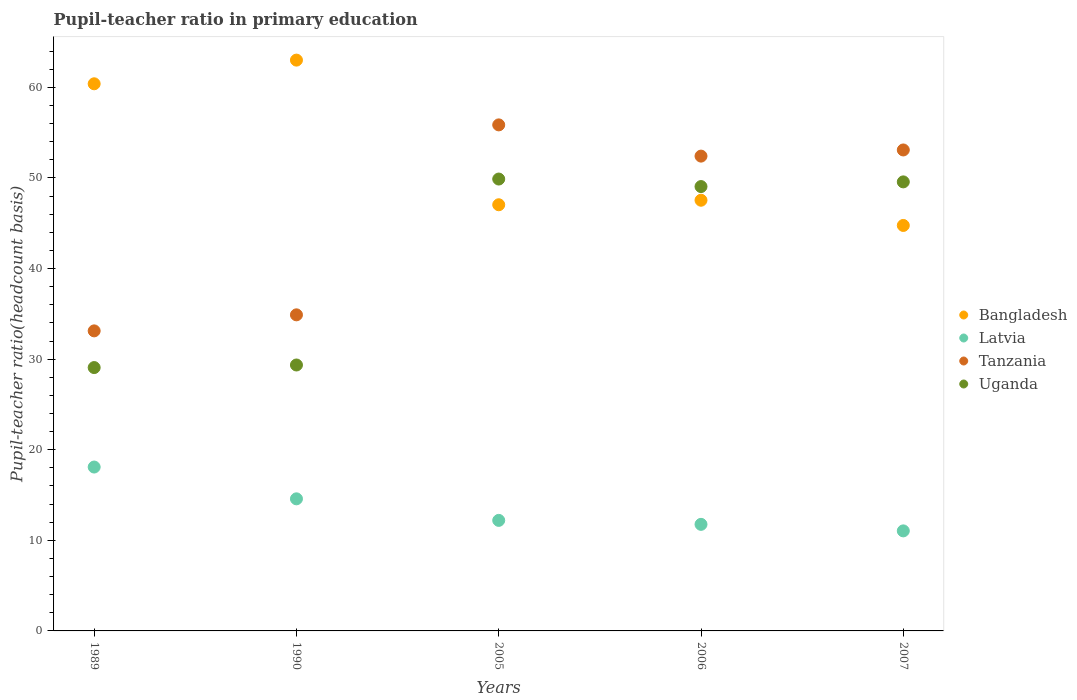How many different coloured dotlines are there?
Offer a very short reply. 4. Is the number of dotlines equal to the number of legend labels?
Give a very brief answer. Yes. What is the pupil-teacher ratio in primary education in Tanzania in 2006?
Keep it short and to the point. 52.41. Across all years, what is the maximum pupil-teacher ratio in primary education in Latvia?
Keep it short and to the point. 18.09. Across all years, what is the minimum pupil-teacher ratio in primary education in Latvia?
Keep it short and to the point. 11.04. In which year was the pupil-teacher ratio in primary education in Uganda minimum?
Offer a very short reply. 1989. What is the total pupil-teacher ratio in primary education in Tanzania in the graph?
Your answer should be compact. 229.36. What is the difference between the pupil-teacher ratio in primary education in Uganda in 1990 and that in 2007?
Make the answer very short. -20.21. What is the difference between the pupil-teacher ratio in primary education in Bangladesh in 1989 and the pupil-teacher ratio in primary education in Uganda in 1990?
Offer a very short reply. 31.04. What is the average pupil-teacher ratio in primary education in Bangladesh per year?
Keep it short and to the point. 52.55. In the year 2005, what is the difference between the pupil-teacher ratio in primary education in Tanzania and pupil-teacher ratio in primary education in Latvia?
Give a very brief answer. 43.65. In how many years, is the pupil-teacher ratio in primary education in Latvia greater than 38?
Your answer should be very brief. 0. What is the ratio of the pupil-teacher ratio in primary education in Bangladesh in 2006 to that in 2007?
Provide a short and direct response. 1.06. What is the difference between the highest and the second highest pupil-teacher ratio in primary education in Bangladesh?
Provide a succinct answer. 2.61. What is the difference between the highest and the lowest pupil-teacher ratio in primary education in Uganda?
Your answer should be compact. 20.81. In how many years, is the pupil-teacher ratio in primary education in Latvia greater than the average pupil-teacher ratio in primary education in Latvia taken over all years?
Your answer should be compact. 2. Is it the case that in every year, the sum of the pupil-teacher ratio in primary education in Tanzania and pupil-teacher ratio in primary education in Latvia  is greater than the sum of pupil-teacher ratio in primary education in Bangladesh and pupil-teacher ratio in primary education in Uganda?
Provide a short and direct response. Yes. Is the pupil-teacher ratio in primary education in Bangladesh strictly greater than the pupil-teacher ratio in primary education in Tanzania over the years?
Your response must be concise. No. How many years are there in the graph?
Offer a terse response. 5. Are the values on the major ticks of Y-axis written in scientific E-notation?
Offer a terse response. No. Does the graph contain any zero values?
Your answer should be very brief. No. Does the graph contain grids?
Provide a succinct answer. No. Where does the legend appear in the graph?
Offer a terse response. Center right. What is the title of the graph?
Your answer should be compact. Pupil-teacher ratio in primary education. Does "Cyprus" appear as one of the legend labels in the graph?
Keep it short and to the point. No. What is the label or title of the Y-axis?
Offer a very short reply. Pupil-teacher ratio(headcount basis). What is the Pupil-teacher ratio(headcount basis) of Bangladesh in 1989?
Your answer should be very brief. 60.39. What is the Pupil-teacher ratio(headcount basis) in Latvia in 1989?
Provide a succinct answer. 18.09. What is the Pupil-teacher ratio(headcount basis) in Tanzania in 1989?
Your answer should be very brief. 33.12. What is the Pupil-teacher ratio(headcount basis) in Uganda in 1989?
Make the answer very short. 29.07. What is the Pupil-teacher ratio(headcount basis) in Bangladesh in 1990?
Ensure brevity in your answer.  63. What is the Pupil-teacher ratio(headcount basis) of Latvia in 1990?
Provide a short and direct response. 14.58. What is the Pupil-teacher ratio(headcount basis) of Tanzania in 1990?
Your answer should be very brief. 34.89. What is the Pupil-teacher ratio(headcount basis) of Uganda in 1990?
Ensure brevity in your answer.  29.35. What is the Pupil-teacher ratio(headcount basis) of Bangladesh in 2005?
Make the answer very short. 47.04. What is the Pupil-teacher ratio(headcount basis) of Latvia in 2005?
Your response must be concise. 12.2. What is the Pupil-teacher ratio(headcount basis) in Tanzania in 2005?
Give a very brief answer. 55.86. What is the Pupil-teacher ratio(headcount basis) of Uganda in 2005?
Keep it short and to the point. 49.88. What is the Pupil-teacher ratio(headcount basis) in Bangladesh in 2006?
Give a very brief answer. 47.54. What is the Pupil-teacher ratio(headcount basis) in Latvia in 2006?
Your answer should be very brief. 11.76. What is the Pupil-teacher ratio(headcount basis) of Tanzania in 2006?
Your response must be concise. 52.41. What is the Pupil-teacher ratio(headcount basis) in Uganda in 2006?
Your response must be concise. 49.05. What is the Pupil-teacher ratio(headcount basis) in Bangladesh in 2007?
Offer a terse response. 44.75. What is the Pupil-teacher ratio(headcount basis) in Latvia in 2007?
Offer a terse response. 11.04. What is the Pupil-teacher ratio(headcount basis) in Tanzania in 2007?
Provide a succinct answer. 53.09. What is the Pupil-teacher ratio(headcount basis) of Uganda in 2007?
Make the answer very short. 49.56. Across all years, what is the maximum Pupil-teacher ratio(headcount basis) of Bangladesh?
Ensure brevity in your answer.  63. Across all years, what is the maximum Pupil-teacher ratio(headcount basis) of Latvia?
Make the answer very short. 18.09. Across all years, what is the maximum Pupil-teacher ratio(headcount basis) of Tanzania?
Give a very brief answer. 55.86. Across all years, what is the maximum Pupil-teacher ratio(headcount basis) in Uganda?
Offer a very short reply. 49.88. Across all years, what is the minimum Pupil-teacher ratio(headcount basis) in Bangladesh?
Offer a very short reply. 44.75. Across all years, what is the minimum Pupil-teacher ratio(headcount basis) of Latvia?
Provide a short and direct response. 11.04. Across all years, what is the minimum Pupil-teacher ratio(headcount basis) in Tanzania?
Keep it short and to the point. 33.12. Across all years, what is the minimum Pupil-teacher ratio(headcount basis) in Uganda?
Provide a succinct answer. 29.07. What is the total Pupil-teacher ratio(headcount basis) in Bangladesh in the graph?
Make the answer very short. 262.73. What is the total Pupil-teacher ratio(headcount basis) in Latvia in the graph?
Keep it short and to the point. 67.67. What is the total Pupil-teacher ratio(headcount basis) in Tanzania in the graph?
Provide a short and direct response. 229.36. What is the total Pupil-teacher ratio(headcount basis) of Uganda in the graph?
Your answer should be compact. 206.91. What is the difference between the Pupil-teacher ratio(headcount basis) of Bangladesh in 1989 and that in 1990?
Your answer should be very brief. -2.61. What is the difference between the Pupil-teacher ratio(headcount basis) in Latvia in 1989 and that in 1990?
Provide a short and direct response. 3.51. What is the difference between the Pupil-teacher ratio(headcount basis) in Tanzania in 1989 and that in 1990?
Your response must be concise. -1.77. What is the difference between the Pupil-teacher ratio(headcount basis) of Uganda in 1989 and that in 1990?
Your answer should be compact. -0.28. What is the difference between the Pupil-teacher ratio(headcount basis) of Bangladesh in 1989 and that in 2005?
Give a very brief answer. 13.35. What is the difference between the Pupil-teacher ratio(headcount basis) of Latvia in 1989 and that in 2005?
Make the answer very short. 5.89. What is the difference between the Pupil-teacher ratio(headcount basis) of Tanzania in 1989 and that in 2005?
Provide a succinct answer. -22.74. What is the difference between the Pupil-teacher ratio(headcount basis) in Uganda in 1989 and that in 2005?
Provide a short and direct response. -20.81. What is the difference between the Pupil-teacher ratio(headcount basis) in Bangladesh in 1989 and that in 2006?
Ensure brevity in your answer.  12.85. What is the difference between the Pupil-teacher ratio(headcount basis) in Latvia in 1989 and that in 2006?
Ensure brevity in your answer.  6.33. What is the difference between the Pupil-teacher ratio(headcount basis) of Tanzania in 1989 and that in 2006?
Keep it short and to the point. -19.29. What is the difference between the Pupil-teacher ratio(headcount basis) in Uganda in 1989 and that in 2006?
Your answer should be very brief. -19.98. What is the difference between the Pupil-teacher ratio(headcount basis) in Bangladesh in 1989 and that in 2007?
Offer a very short reply. 15.64. What is the difference between the Pupil-teacher ratio(headcount basis) of Latvia in 1989 and that in 2007?
Give a very brief answer. 7.05. What is the difference between the Pupil-teacher ratio(headcount basis) in Tanzania in 1989 and that in 2007?
Provide a short and direct response. -19.97. What is the difference between the Pupil-teacher ratio(headcount basis) in Uganda in 1989 and that in 2007?
Ensure brevity in your answer.  -20.5. What is the difference between the Pupil-teacher ratio(headcount basis) of Bangladesh in 1990 and that in 2005?
Ensure brevity in your answer.  15.97. What is the difference between the Pupil-teacher ratio(headcount basis) of Latvia in 1990 and that in 2005?
Your answer should be compact. 2.38. What is the difference between the Pupil-teacher ratio(headcount basis) of Tanzania in 1990 and that in 2005?
Your response must be concise. -20.97. What is the difference between the Pupil-teacher ratio(headcount basis) of Uganda in 1990 and that in 2005?
Provide a short and direct response. -20.52. What is the difference between the Pupil-teacher ratio(headcount basis) of Bangladesh in 1990 and that in 2006?
Offer a terse response. 15.47. What is the difference between the Pupil-teacher ratio(headcount basis) of Latvia in 1990 and that in 2006?
Ensure brevity in your answer.  2.82. What is the difference between the Pupil-teacher ratio(headcount basis) in Tanzania in 1990 and that in 2006?
Make the answer very short. -17.52. What is the difference between the Pupil-teacher ratio(headcount basis) in Uganda in 1990 and that in 2006?
Offer a terse response. -19.69. What is the difference between the Pupil-teacher ratio(headcount basis) in Bangladesh in 1990 and that in 2007?
Your answer should be compact. 18.25. What is the difference between the Pupil-teacher ratio(headcount basis) of Latvia in 1990 and that in 2007?
Your answer should be very brief. 3.54. What is the difference between the Pupil-teacher ratio(headcount basis) of Tanzania in 1990 and that in 2007?
Offer a very short reply. -18.2. What is the difference between the Pupil-teacher ratio(headcount basis) in Uganda in 1990 and that in 2007?
Keep it short and to the point. -20.21. What is the difference between the Pupil-teacher ratio(headcount basis) of Bangladesh in 2005 and that in 2006?
Your answer should be compact. -0.5. What is the difference between the Pupil-teacher ratio(headcount basis) in Latvia in 2005 and that in 2006?
Your answer should be very brief. 0.44. What is the difference between the Pupil-teacher ratio(headcount basis) in Tanzania in 2005 and that in 2006?
Your response must be concise. 3.45. What is the difference between the Pupil-teacher ratio(headcount basis) in Uganda in 2005 and that in 2006?
Offer a very short reply. 0.83. What is the difference between the Pupil-teacher ratio(headcount basis) in Bangladesh in 2005 and that in 2007?
Your response must be concise. 2.28. What is the difference between the Pupil-teacher ratio(headcount basis) in Latvia in 2005 and that in 2007?
Offer a terse response. 1.16. What is the difference between the Pupil-teacher ratio(headcount basis) in Tanzania in 2005 and that in 2007?
Your response must be concise. 2.77. What is the difference between the Pupil-teacher ratio(headcount basis) in Uganda in 2005 and that in 2007?
Your answer should be compact. 0.31. What is the difference between the Pupil-teacher ratio(headcount basis) in Bangladesh in 2006 and that in 2007?
Your response must be concise. 2.78. What is the difference between the Pupil-teacher ratio(headcount basis) of Latvia in 2006 and that in 2007?
Provide a succinct answer. 0.72. What is the difference between the Pupil-teacher ratio(headcount basis) of Tanzania in 2006 and that in 2007?
Provide a succinct answer. -0.68. What is the difference between the Pupil-teacher ratio(headcount basis) in Uganda in 2006 and that in 2007?
Give a very brief answer. -0.52. What is the difference between the Pupil-teacher ratio(headcount basis) of Bangladesh in 1989 and the Pupil-teacher ratio(headcount basis) of Latvia in 1990?
Provide a succinct answer. 45.81. What is the difference between the Pupil-teacher ratio(headcount basis) in Bangladesh in 1989 and the Pupil-teacher ratio(headcount basis) in Tanzania in 1990?
Offer a very short reply. 25.5. What is the difference between the Pupil-teacher ratio(headcount basis) of Bangladesh in 1989 and the Pupil-teacher ratio(headcount basis) of Uganda in 1990?
Offer a very short reply. 31.04. What is the difference between the Pupil-teacher ratio(headcount basis) in Latvia in 1989 and the Pupil-teacher ratio(headcount basis) in Tanzania in 1990?
Your answer should be very brief. -16.8. What is the difference between the Pupil-teacher ratio(headcount basis) of Latvia in 1989 and the Pupil-teacher ratio(headcount basis) of Uganda in 1990?
Ensure brevity in your answer.  -11.26. What is the difference between the Pupil-teacher ratio(headcount basis) of Tanzania in 1989 and the Pupil-teacher ratio(headcount basis) of Uganda in 1990?
Keep it short and to the point. 3.77. What is the difference between the Pupil-teacher ratio(headcount basis) in Bangladesh in 1989 and the Pupil-teacher ratio(headcount basis) in Latvia in 2005?
Give a very brief answer. 48.19. What is the difference between the Pupil-teacher ratio(headcount basis) in Bangladesh in 1989 and the Pupil-teacher ratio(headcount basis) in Tanzania in 2005?
Provide a succinct answer. 4.54. What is the difference between the Pupil-teacher ratio(headcount basis) in Bangladesh in 1989 and the Pupil-teacher ratio(headcount basis) in Uganda in 2005?
Give a very brief answer. 10.51. What is the difference between the Pupil-teacher ratio(headcount basis) of Latvia in 1989 and the Pupil-teacher ratio(headcount basis) of Tanzania in 2005?
Keep it short and to the point. -37.77. What is the difference between the Pupil-teacher ratio(headcount basis) of Latvia in 1989 and the Pupil-teacher ratio(headcount basis) of Uganda in 2005?
Your answer should be very brief. -31.79. What is the difference between the Pupil-teacher ratio(headcount basis) of Tanzania in 1989 and the Pupil-teacher ratio(headcount basis) of Uganda in 2005?
Ensure brevity in your answer.  -16.76. What is the difference between the Pupil-teacher ratio(headcount basis) in Bangladesh in 1989 and the Pupil-teacher ratio(headcount basis) in Latvia in 2006?
Ensure brevity in your answer.  48.63. What is the difference between the Pupil-teacher ratio(headcount basis) of Bangladesh in 1989 and the Pupil-teacher ratio(headcount basis) of Tanzania in 2006?
Your answer should be very brief. 7.98. What is the difference between the Pupil-teacher ratio(headcount basis) of Bangladesh in 1989 and the Pupil-teacher ratio(headcount basis) of Uganda in 2006?
Your response must be concise. 11.34. What is the difference between the Pupil-teacher ratio(headcount basis) of Latvia in 1989 and the Pupil-teacher ratio(headcount basis) of Tanzania in 2006?
Give a very brief answer. -34.32. What is the difference between the Pupil-teacher ratio(headcount basis) of Latvia in 1989 and the Pupil-teacher ratio(headcount basis) of Uganda in 2006?
Offer a terse response. -30.96. What is the difference between the Pupil-teacher ratio(headcount basis) in Tanzania in 1989 and the Pupil-teacher ratio(headcount basis) in Uganda in 2006?
Make the answer very short. -15.93. What is the difference between the Pupil-teacher ratio(headcount basis) in Bangladesh in 1989 and the Pupil-teacher ratio(headcount basis) in Latvia in 2007?
Provide a succinct answer. 49.35. What is the difference between the Pupil-teacher ratio(headcount basis) of Bangladesh in 1989 and the Pupil-teacher ratio(headcount basis) of Tanzania in 2007?
Provide a succinct answer. 7.3. What is the difference between the Pupil-teacher ratio(headcount basis) of Bangladesh in 1989 and the Pupil-teacher ratio(headcount basis) of Uganda in 2007?
Offer a very short reply. 10.83. What is the difference between the Pupil-teacher ratio(headcount basis) of Latvia in 1989 and the Pupil-teacher ratio(headcount basis) of Tanzania in 2007?
Offer a terse response. -35. What is the difference between the Pupil-teacher ratio(headcount basis) of Latvia in 1989 and the Pupil-teacher ratio(headcount basis) of Uganda in 2007?
Your response must be concise. -31.48. What is the difference between the Pupil-teacher ratio(headcount basis) of Tanzania in 1989 and the Pupil-teacher ratio(headcount basis) of Uganda in 2007?
Your answer should be compact. -16.45. What is the difference between the Pupil-teacher ratio(headcount basis) in Bangladesh in 1990 and the Pupil-teacher ratio(headcount basis) in Latvia in 2005?
Provide a succinct answer. 50.8. What is the difference between the Pupil-teacher ratio(headcount basis) of Bangladesh in 1990 and the Pupil-teacher ratio(headcount basis) of Tanzania in 2005?
Ensure brevity in your answer.  7.15. What is the difference between the Pupil-teacher ratio(headcount basis) of Bangladesh in 1990 and the Pupil-teacher ratio(headcount basis) of Uganda in 2005?
Offer a very short reply. 13.13. What is the difference between the Pupil-teacher ratio(headcount basis) in Latvia in 1990 and the Pupil-teacher ratio(headcount basis) in Tanzania in 2005?
Provide a short and direct response. -41.28. What is the difference between the Pupil-teacher ratio(headcount basis) of Latvia in 1990 and the Pupil-teacher ratio(headcount basis) of Uganda in 2005?
Make the answer very short. -35.3. What is the difference between the Pupil-teacher ratio(headcount basis) of Tanzania in 1990 and the Pupil-teacher ratio(headcount basis) of Uganda in 2005?
Offer a very short reply. -14.99. What is the difference between the Pupil-teacher ratio(headcount basis) in Bangladesh in 1990 and the Pupil-teacher ratio(headcount basis) in Latvia in 2006?
Your answer should be compact. 51.24. What is the difference between the Pupil-teacher ratio(headcount basis) of Bangladesh in 1990 and the Pupil-teacher ratio(headcount basis) of Tanzania in 2006?
Offer a terse response. 10.6. What is the difference between the Pupil-teacher ratio(headcount basis) in Bangladesh in 1990 and the Pupil-teacher ratio(headcount basis) in Uganda in 2006?
Your response must be concise. 13.96. What is the difference between the Pupil-teacher ratio(headcount basis) of Latvia in 1990 and the Pupil-teacher ratio(headcount basis) of Tanzania in 2006?
Give a very brief answer. -37.83. What is the difference between the Pupil-teacher ratio(headcount basis) in Latvia in 1990 and the Pupil-teacher ratio(headcount basis) in Uganda in 2006?
Give a very brief answer. -34.47. What is the difference between the Pupil-teacher ratio(headcount basis) of Tanzania in 1990 and the Pupil-teacher ratio(headcount basis) of Uganda in 2006?
Offer a very short reply. -14.16. What is the difference between the Pupil-teacher ratio(headcount basis) in Bangladesh in 1990 and the Pupil-teacher ratio(headcount basis) in Latvia in 2007?
Your response must be concise. 51.96. What is the difference between the Pupil-teacher ratio(headcount basis) of Bangladesh in 1990 and the Pupil-teacher ratio(headcount basis) of Tanzania in 2007?
Offer a terse response. 9.92. What is the difference between the Pupil-teacher ratio(headcount basis) in Bangladesh in 1990 and the Pupil-teacher ratio(headcount basis) in Uganda in 2007?
Offer a very short reply. 13.44. What is the difference between the Pupil-teacher ratio(headcount basis) of Latvia in 1990 and the Pupil-teacher ratio(headcount basis) of Tanzania in 2007?
Make the answer very short. -38.51. What is the difference between the Pupil-teacher ratio(headcount basis) in Latvia in 1990 and the Pupil-teacher ratio(headcount basis) in Uganda in 2007?
Make the answer very short. -34.98. What is the difference between the Pupil-teacher ratio(headcount basis) in Tanzania in 1990 and the Pupil-teacher ratio(headcount basis) in Uganda in 2007?
Offer a very short reply. -14.67. What is the difference between the Pupil-teacher ratio(headcount basis) in Bangladesh in 2005 and the Pupil-teacher ratio(headcount basis) in Latvia in 2006?
Make the answer very short. 35.28. What is the difference between the Pupil-teacher ratio(headcount basis) of Bangladesh in 2005 and the Pupil-teacher ratio(headcount basis) of Tanzania in 2006?
Your answer should be very brief. -5.37. What is the difference between the Pupil-teacher ratio(headcount basis) in Bangladesh in 2005 and the Pupil-teacher ratio(headcount basis) in Uganda in 2006?
Your response must be concise. -2.01. What is the difference between the Pupil-teacher ratio(headcount basis) in Latvia in 2005 and the Pupil-teacher ratio(headcount basis) in Tanzania in 2006?
Keep it short and to the point. -40.21. What is the difference between the Pupil-teacher ratio(headcount basis) in Latvia in 2005 and the Pupil-teacher ratio(headcount basis) in Uganda in 2006?
Your response must be concise. -36.85. What is the difference between the Pupil-teacher ratio(headcount basis) of Tanzania in 2005 and the Pupil-teacher ratio(headcount basis) of Uganda in 2006?
Ensure brevity in your answer.  6.81. What is the difference between the Pupil-teacher ratio(headcount basis) in Bangladesh in 2005 and the Pupil-teacher ratio(headcount basis) in Latvia in 2007?
Provide a short and direct response. 36. What is the difference between the Pupil-teacher ratio(headcount basis) of Bangladesh in 2005 and the Pupil-teacher ratio(headcount basis) of Tanzania in 2007?
Ensure brevity in your answer.  -6.05. What is the difference between the Pupil-teacher ratio(headcount basis) in Bangladesh in 2005 and the Pupil-teacher ratio(headcount basis) in Uganda in 2007?
Give a very brief answer. -2.52. What is the difference between the Pupil-teacher ratio(headcount basis) in Latvia in 2005 and the Pupil-teacher ratio(headcount basis) in Tanzania in 2007?
Make the answer very short. -40.89. What is the difference between the Pupil-teacher ratio(headcount basis) in Latvia in 2005 and the Pupil-teacher ratio(headcount basis) in Uganda in 2007?
Your answer should be compact. -37.36. What is the difference between the Pupil-teacher ratio(headcount basis) in Tanzania in 2005 and the Pupil-teacher ratio(headcount basis) in Uganda in 2007?
Your response must be concise. 6.29. What is the difference between the Pupil-teacher ratio(headcount basis) of Bangladesh in 2006 and the Pupil-teacher ratio(headcount basis) of Latvia in 2007?
Your answer should be very brief. 36.5. What is the difference between the Pupil-teacher ratio(headcount basis) in Bangladesh in 2006 and the Pupil-teacher ratio(headcount basis) in Tanzania in 2007?
Make the answer very short. -5.55. What is the difference between the Pupil-teacher ratio(headcount basis) of Bangladesh in 2006 and the Pupil-teacher ratio(headcount basis) of Uganda in 2007?
Your answer should be compact. -2.02. What is the difference between the Pupil-teacher ratio(headcount basis) in Latvia in 2006 and the Pupil-teacher ratio(headcount basis) in Tanzania in 2007?
Your response must be concise. -41.33. What is the difference between the Pupil-teacher ratio(headcount basis) in Latvia in 2006 and the Pupil-teacher ratio(headcount basis) in Uganda in 2007?
Provide a succinct answer. -37.8. What is the difference between the Pupil-teacher ratio(headcount basis) of Tanzania in 2006 and the Pupil-teacher ratio(headcount basis) of Uganda in 2007?
Keep it short and to the point. 2.84. What is the average Pupil-teacher ratio(headcount basis) of Bangladesh per year?
Provide a succinct answer. 52.55. What is the average Pupil-teacher ratio(headcount basis) in Latvia per year?
Offer a terse response. 13.53. What is the average Pupil-teacher ratio(headcount basis) of Tanzania per year?
Offer a very short reply. 45.87. What is the average Pupil-teacher ratio(headcount basis) of Uganda per year?
Your answer should be compact. 41.38. In the year 1989, what is the difference between the Pupil-teacher ratio(headcount basis) in Bangladesh and Pupil-teacher ratio(headcount basis) in Latvia?
Offer a very short reply. 42.3. In the year 1989, what is the difference between the Pupil-teacher ratio(headcount basis) in Bangladesh and Pupil-teacher ratio(headcount basis) in Tanzania?
Keep it short and to the point. 27.27. In the year 1989, what is the difference between the Pupil-teacher ratio(headcount basis) of Bangladesh and Pupil-teacher ratio(headcount basis) of Uganda?
Ensure brevity in your answer.  31.32. In the year 1989, what is the difference between the Pupil-teacher ratio(headcount basis) of Latvia and Pupil-teacher ratio(headcount basis) of Tanzania?
Your answer should be compact. -15.03. In the year 1989, what is the difference between the Pupil-teacher ratio(headcount basis) of Latvia and Pupil-teacher ratio(headcount basis) of Uganda?
Give a very brief answer. -10.98. In the year 1989, what is the difference between the Pupil-teacher ratio(headcount basis) of Tanzania and Pupil-teacher ratio(headcount basis) of Uganda?
Your answer should be compact. 4.05. In the year 1990, what is the difference between the Pupil-teacher ratio(headcount basis) of Bangladesh and Pupil-teacher ratio(headcount basis) of Latvia?
Your answer should be very brief. 48.43. In the year 1990, what is the difference between the Pupil-teacher ratio(headcount basis) of Bangladesh and Pupil-teacher ratio(headcount basis) of Tanzania?
Provide a short and direct response. 28.12. In the year 1990, what is the difference between the Pupil-teacher ratio(headcount basis) of Bangladesh and Pupil-teacher ratio(headcount basis) of Uganda?
Offer a very short reply. 33.65. In the year 1990, what is the difference between the Pupil-teacher ratio(headcount basis) in Latvia and Pupil-teacher ratio(headcount basis) in Tanzania?
Offer a terse response. -20.31. In the year 1990, what is the difference between the Pupil-teacher ratio(headcount basis) of Latvia and Pupil-teacher ratio(headcount basis) of Uganda?
Offer a terse response. -14.77. In the year 1990, what is the difference between the Pupil-teacher ratio(headcount basis) in Tanzania and Pupil-teacher ratio(headcount basis) in Uganda?
Keep it short and to the point. 5.54. In the year 2005, what is the difference between the Pupil-teacher ratio(headcount basis) of Bangladesh and Pupil-teacher ratio(headcount basis) of Latvia?
Your answer should be compact. 34.84. In the year 2005, what is the difference between the Pupil-teacher ratio(headcount basis) of Bangladesh and Pupil-teacher ratio(headcount basis) of Tanzania?
Provide a succinct answer. -8.82. In the year 2005, what is the difference between the Pupil-teacher ratio(headcount basis) in Bangladesh and Pupil-teacher ratio(headcount basis) in Uganda?
Offer a very short reply. -2.84. In the year 2005, what is the difference between the Pupil-teacher ratio(headcount basis) in Latvia and Pupil-teacher ratio(headcount basis) in Tanzania?
Give a very brief answer. -43.65. In the year 2005, what is the difference between the Pupil-teacher ratio(headcount basis) of Latvia and Pupil-teacher ratio(headcount basis) of Uganda?
Your response must be concise. -37.68. In the year 2005, what is the difference between the Pupil-teacher ratio(headcount basis) of Tanzania and Pupil-teacher ratio(headcount basis) of Uganda?
Offer a terse response. 5.98. In the year 2006, what is the difference between the Pupil-teacher ratio(headcount basis) in Bangladesh and Pupil-teacher ratio(headcount basis) in Latvia?
Give a very brief answer. 35.78. In the year 2006, what is the difference between the Pupil-teacher ratio(headcount basis) of Bangladesh and Pupil-teacher ratio(headcount basis) of Tanzania?
Give a very brief answer. -4.87. In the year 2006, what is the difference between the Pupil-teacher ratio(headcount basis) in Bangladesh and Pupil-teacher ratio(headcount basis) in Uganda?
Your response must be concise. -1.51. In the year 2006, what is the difference between the Pupil-teacher ratio(headcount basis) in Latvia and Pupil-teacher ratio(headcount basis) in Tanzania?
Provide a succinct answer. -40.65. In the year 2006, what is the difference between the Pupil-teacher ratio(headcount basis) in Latvia and Pupil-teacher ratio(headcount basis) in Uganda?
Offer a very short reply. -37.28. In the year 2006, what is the difference between the Pupil-teacher ratio(headcount basis) of Tanzania and Pupil-teacher ratio(headcount basis) of Uganda?
Keep it short and to the point. 3.36. In the year 2007, what is the difference between the Pupil-teacher ratio(headcount basis) in Bangladesh and Pupil-teacher ratio(headcount basis) in Latvia?
Your response must be concise. 33.71. In the year 2007, what is the difference between the Pupil-teacher ratio(headcount basis) in Bangladesh and Pupil-teacher ratio(headcount basis) in Tanzania?
Make the answer very short. -8.33. In the year 2007, what is the difference between the Pupil-teacher ratio(headcount basis) in Bangladesh and Pupil-teacher ratio(headcount basis) in Uganda?
Provide a succinct answer. -4.81. In the year 2007, what is the difference between the Pupil-teacher ratio(headcount basis) of Latvia and Pupil-teacher ratio(headcount basis) of Tanzania?
Ensure brevity in your answer.  -42.05. In the year 2007, what is the difference between the Pupil-teacher ratio(headcount basis) in Latvia and Pupil-teacher ratio(headcount basis) in Uganda?
Your answer should be compact. -38.52. In the year 2007, what is the difference between the Pupil-teacher ratio(headcount basis) of Tanzania and Pupil-teacher ratio(headcount basis) of Uganda?
Offer a very short reply. 3.52. What is the ratio of the Pupil-teacher ratio(headcount basis) of Bangladesh in 1989 to that in 1990?
Make the answer very short. 0.96. What is the ratio of the Pupil-teacher ratio(headcount basis) in Latvia in 1989 to that in 1990?
Keep it short and to the point. 1.24. What is the ratio of the Pupil-teacher ratio(headcount basis) of Tanzania in 1989 to that in 1990?
Provide a short and direct response. 0.95. What is the ratio of the Pupil-teacher ratio(headcount basis) in Uganda in 1989 to that in 1990?
Your answer should be very brief. 0.99. What is the ratio of the Pupil-teacher ratio(headcount basis) in Bangladesh in 1989 to that in 2005?
Your answer should be very brief. 1.28. What is the ratio of the Pupil-teacher ratio(headcount basis) in Latvia in 1989 to that in 2005?
Ensure brevity in your answer.  1.48. What is the ratio of the Pupil-teacher ratio(headcount basis) in Tanzania in 1989 to that in 2005?
Make the answer very short. 0.59. What is the ratio of the Pupil-teacher ratio(headcount basis) in Uganda in 1989 to that in 2005?
Your response must be concise. 0.58. What is the ratio of the Pupil-teacher ratio(headcount basis) of Bangladesh in 1989 to that in 2006?
Provide a succinct answer. 1.27. What is the ratio of the Pupil-teacher ratio(headcount basis) in Latvia in 1989 to that in 2006?
Your answer should be compact. 1.54. What is the ratio of the Pupil-teacher ratio(headcount basis) of Tanzania in 1989 to that in 2006?
Provide a succinct answer. 0.63. What is the ratio of the Pupil-teacher ratio(headcount basis) in Uganda in 1989 to that in 2006?
Provide a succinct answer. 0.59. What is the ratio of the Pupil-teacher ratio(headcount basis) of Bangladesh in 1989 to that in 2007?
Provide a succinct answer. 1.35. What is the ratio of the Pupil-teacher ratio(headcount basis) in Latvia in 1989 to that in 2007?
Your answer should be very brief. 1.64. What is the ratio of the Pupil-teacher ratio(headcount basis) of Tanzania in 1989 to that in 2007?
Your answer should be very brief. 0.62. What is the ratio of the Pupil-teacher ratio(headcount basis) in Uganda in 1989 to that in 2007?
Make the answer very short. 0.59. What is the ratio of the Pupil-teacher ratio(headcount basis) in Bangladesh in 1990 to that in 2005?
Keep it short and to the point. 1.34. What is the ratio of the Pupil-teacher ratio(headcount basis) of Latvia in 1990 to that in 2005?
Offer a terse response. 1.2. What is the ratio of the Pupil-teacher ratio(headcount basis) of Tanzania in 1990 to that in 2005?
Offer a very short reply. 0.62. What is the ratio of the Pupil-teacher ratio(headcount basis) in Uganda in 1990 to that in 2005?
Offer a terse response. 0.59. What is the ratio of the Pupil-teacher ratio(headcount basis) of Bangladesh in 1990 to that in 2006?
Keep it short and to the point. 1.33. What is the ratio of the Pupil-teacher ratio(headcount basis) of Latvia in 1990 to that in 2006?
Ensure brevity in your answer.  1.24. What is the ratio of the Pupil-teacher ratio(headcount basis) in Tanzania in 1990 to that in 2006?
Your response must be concise. 0.67. What is the ratio of the Pupil-teacher ratio(headcount basis) of Uganda in 1990 to that in 2006?
Your answer should be compact. 0.6. What is the ratio of the Pupil-teacher ratio(headcount basis) of Bangladesh in 1990 to that in 2007?
Provide a succinct answer. 1.41. What is the ratio of the Pupil-teacher ratio(headcount basis) in Latvia in 1990 to that in 2007?
Ensure brevity in your answer.  1.32. What is the ratio of the Pupil-teacher ratio(headcount basis) in Tanzania in 1990 to that in 2007?
Give a very brief answer. 0.66. What is the ratio of the Pupil-teacher ratio(headcount basis) in Uganda in 1990 to that in 2007?
Make the answer very short. 0.59. What is the ratio of the Pupil-teacher ratio(headcount basis) in Latvia in 2005 to that in 2006?
Provide a short and direct response. 1.04. What is the ratio of the Pupil-teacher ratio(headcount basis) in Tanzania in 2005 to that in 2006?
Give a very brief answer. 1.07. What is the ratio of the Pupil-teacher ratio(headcount basis) in Uganda in 2005 to that in 2006?
Keep it short and to the point. 1.02. What is the ratio of the Pupil-teacher ratio(headcount basis) in Bangladesh in 2005 to that in 2007?
Make the answer very short. 1.05. What is the ratio of the Pupil-teacher ratio(headcount basis) in Latvia in 2005 to that in 2007?
Give a very brief answer. 1.1. What is the ratio of the Pupil-teacher ratio(headcount basis) of Tanzania in 2005 to that in 2007?
Ensure brevity in your answer.  1.05. What is the ratio of the Pupil-teacher ratio(headcount basis) of Uganda in 2005 to that in 2007?
Provide a short and direct response. 1.01. What is the ratio of the Pupil-teacher ratio(headcount basis) in Bangladesh in 2006 to that in 2007?
Provide a succinct answer. 1.06. What is the ratio of the Pupil-teacher ratio(headcount basis) of Latvia in 2006 to that in 2007?
Offer a terse response. 1.07. What is the ratio of the Pupil-teacher ratio(headcount basis) of Tanzania in 2006 to that in 2007?
Provide a short and direct response. 0.99. What is the ratio of the Pupil-teacher ratio(headcount basis) of Uganda in 2006 to that in 2007?
Offer a terse response. 0.99. What is the difference between the highest and the second highest Pupil-teacher ratio(headcount basis) of Bangladesh?
Your answer should be compact. 2.61. What is the difference between the highest and the second highest Pupil-teacher ratio(headcount basis) of Latvia?
Your answer should be compact. 3.51. What is the difference between the highest and the second highest Pupil-teacher ratio(headcount basis) of Tanzania?
Provide a succinct answer. 2.77. What is the difference between the highest and the second highest Pupil-teacher ratio(headcount basis) of Uganda?
Offer a terse response. 0.31. What is the difference between the highest and the lowest Pupil-teacher ratio(headcount basis) of Bangladesh?
Your answer should be very brief. 18.25. What is the difference between the highest and the lowest Pupil-teacher ratio(headcount basis) in Latvia?
Provide a short and direct response. 7.05. What is the difference between the highest and the lowest Pupil-teacher ratio(headcount basis) in Tanzania?
Provide a succinct answer. 22.74. What is the difference between the highest and the lowest Pupil-teacher ratio(headcount basis) of Uganda?
Your response must be concise. 20.81. 